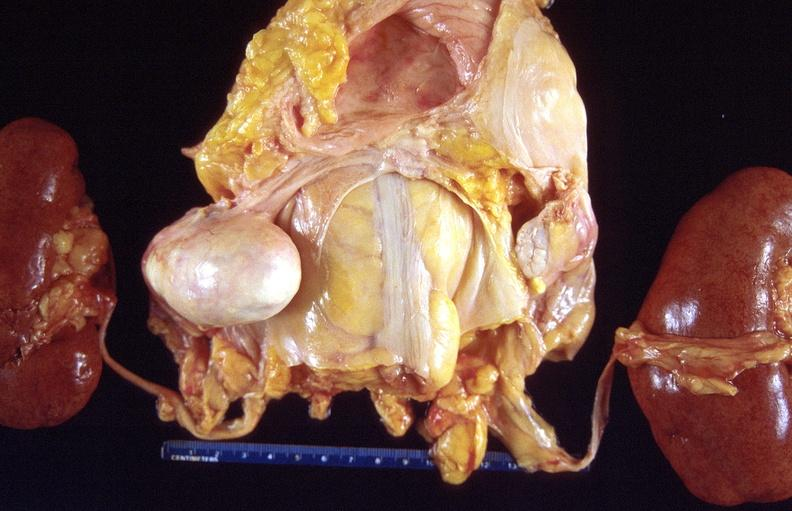does this image show dermoid cyst?
Answer the question using a single word or phrase. Yes 